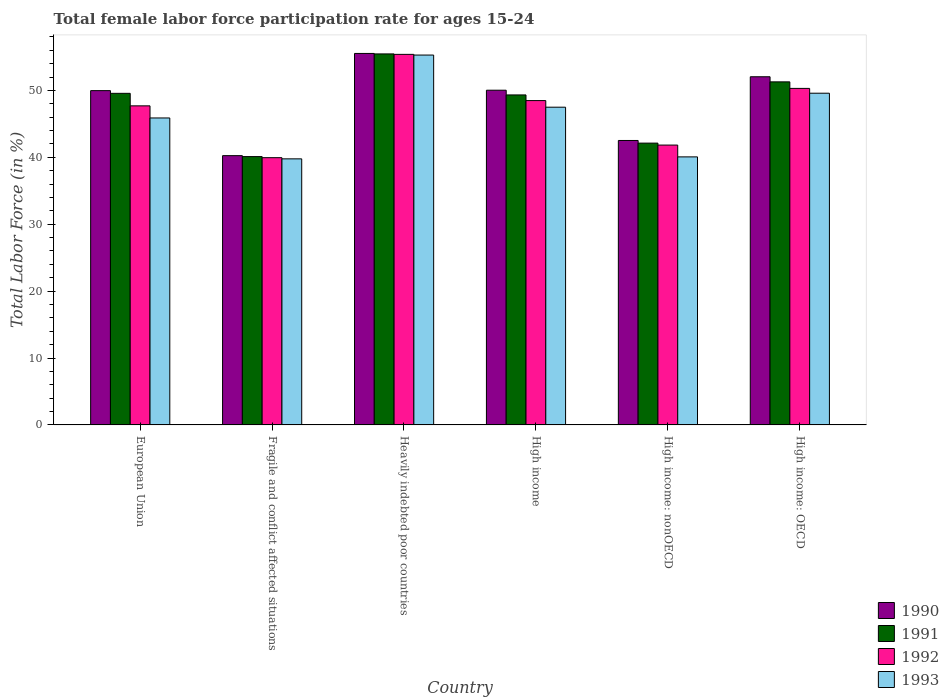How many different coloured bars are there?
Give a very brief answer. 4. How many groups of bars are there?
Give a very brief answer. 6. Are the number of bars per tick equal to the number of legend labels?
Provide a succinct answer. Yes. How many bars are there on the 1st tick from the right?
Provide a short and direct response. 4. What is the label of the 3rd group of bars from the left?
Offer a very short reply. Heavily indebted poor countries. What is the female labor force participation rate in 1991 in European Union?
Ensure brevity in your answer.  49.57. Across all countries, what is the maximum female labor force participation rate in 1992?
Offer a very short reply. 55.39. Across all countries, what is the minimum female labor force participation rate in 1992?
Give a very brief answer. 39.95. In which country was the female labor force participation rate in 1993 maximum?
Offer a terse response. Heavily indebted poor countries. In which country was the female labor force participation rate in 1990 minimum?
Give a very brief answer. Fragile and conflict affected situations. What is the total female labor force participation rate in 1991 in the graph?
Offer a very short reply. 287.87. What is the difference between the female labor force participation rate in 1991 in Fragile and conflict affected situations and that in High income: OECD?
Make the answer very short. -11.17. What is the difference between the female labor force participation rate in 1992 in High income: nonOECD and the female labor force participation rate in 1991 in High income: OECD?
Make the answer very short. -9.45. What is the average female labor force participation rate in 1991 per country?
Give a very brief answer. 47.98. What is the difference between the female labor force participation rate of/in 1991 and female labor force participation rate of/in 1990 in High income: OECD?
Provide a short and direct response. -0.76. What is the ratio of the female labor force participation rate in 1991 in Fragile and conflict affected situations to that in Heavily indebted poor countries?
Your answer should be compact. 0.72. Is the female labor force participation rate in 1992 in European Union less than that in Fragile and conflict affected situations?
Give a very brief answer. No. Is the difference between the female labor force participation rate in 1991 in European Union and High income greater than the difference between the female labor force participation rate in 1990 in European Union and High income?
Provide a short and direct response. Yes. What is the difference between the highest and the second highest female labor force participation rate in 1993?
Your answer should be compact. 2.09. What is the difference between the highest and the lowest female labor force participation rate in 1991?
Ensure brevity in your answer.  15.35. Is the sum of the female labor force participation rate in 1992 in Heavily indebted poor countries and High income greater than the maximum female labor force participation rate in 1993 across all countries?
Give a very brief answer. Yes. Is it the case that in every country, the sum of the female labor force participation rate in 1990 and female labor force participation rate in 1992 is greater than the sum of female labor force participation rate in 1991 and female labor force participation rate in 1993?
Offer a terse response. No. What does the 4th bar from the left in Fragile and conflict affected situations represents?
Your answer should be very brief. 1993. Is it the case that in every country, the sum of the female labor force participation rate in 1992 and female labor force participation rate in 1991 is greater than the female labor force participation rate in 1990?
Your answer should be compact. Yes. What is the difference between two consecutive major ticks on the Y-axis?
Your answer should be compact. 10. Are the values on the major ticks of Y-axis written in scientific E-notation?
Offer a terse response. No. Does the graph contain grids?
Keep it short and to the point. No. Where does the legend appear in the graph?
Keep it short and to the point. Bottom right. How are the legend labels stacked?
Your response must be concise. Vertical. What is the title of the graph?
Keep it short and to the point. Total female labor force participation rate for ages 15-24. What is the Total Labor Force (in %) of 1990 in European Union?
Your response must be concise. 49.97. What is the Total Labor Force (in %) of 1991 in European Union?
Provide a short and direct response. 49.57. What is the Total Labor Force (in %) of 1992 in European Union?
Your response must be concise. 47.7. What is the Total Labor Force (in %) of 1993 in European Union?
Keep it short and to the point. 45.89. What is the Total Labor Force (in %) of 1990 in Fragile and conflict affected situations?
Give a very brief answer. 40.25. What is the Total Labor Force (in %) of 1991 in Fragile and conflict affected situations?
Ensure brevity in your answer.  40.11. What is the Total Labor Force (in %) of 1992 in Fragile and conflict affected situations?
Your response must be concise. 39.95. What is the Total Labor Force (in %) of 1993 in Fragile and conflict affected situations?
Your answer should be compact. 39.77. What is the Total Labor Force (in %) of 1990 in Heavily indebted poor countries?
Your answer should be compact. 55.53. What is the Total Labor Force (in %) in 1991 in Heavily indebted poor countries?
Provide a short and direct response. 55.46. What is the Total Labor Force (in %) in 1992 in Heavily indebted poor countries?
Give a very brief answer. 55.39. What is the Total Labor Force (in %) of 1993 in Heavily indebted poor countries?
Keep it short and to the point. 55.29. What is the Total Labor Force (in %) of 1990 in High income?
Your answer should be very brief. 50.03. What is the Total Labor Force (in %) in 1991 in High income?
Offer a very short reply. 49.33. What is the Total Labor Force (in %) in 1992 in High income?
Your response must be concise. 48.48. What is the Total Labor Force (in %) of 1993 in High income?
Ensure brevity in your answer.  47.5. What is the Total Labor Force (in %) in 1990 in High income: nonOECD?
Provide a short and direct response. 42.52. What is the Total Labor Force (in %) of 1991 in High income: nonOECD?
Provide a succinct answer. 42.12. What is the Total Labor Force (in %) of 1992 in High income: nonOECD?
Offer a very short reply. 41.83. What is the Total Labor Force (in %) in 1993 in High income: nonOECD?
Make the answer very short. 40.07. What is the Total Labor Force (in %) of 1990 in High income: OECD?
Make the answer very short. 52.04. What is the Total Labor Force (in %) of 1991 in High income: OECD?
Offer a terse response. 51.28. What is the Total Labor Force (in %) of 1992 in High income: OECD?
Give a very brief answer. 50.3. What is the Total Labor Force (in %) in 1993 in High income: OECD?
Your answer should be compact. 49.59. Across all countries, what is the maximum Total Labor Force (in %) of 1990?
Offer a terse response. 55.53. Across all countries, what is the maximum Total Labor Force (in %) in 1991?
Keep it short and to the point. 55.46. Across all countries, what is the maximum Total Labor Force (in %) in 1992?
Ensure brevity in your answer.  55.39. Across all countries, what is the maximum Total Labor Force (in %) of 1993?
Keep it short and to the point. 55.29. Across all countries, what is the minimum Total Labor Force (in %) in 1990?
Offer a terse response. 40.25. Across all countries, what is the minimum Total Labor Force (in %) of 1991?
Provide a succinct answer. 40.11. Across all countries, what is the minimum Total Labor Force (in %) in 1992?
Provide a succinct answer. 39.95. Across all countries, what is the minimum Total Labor Force (in %) of 1993?
Your answer should be compact. 39.77. What is the total Total Labor Force (in %) of 1990 in the graph?
Make the answer very short. 290.35. What is the total Total Labor Force (in %) in 1991 in the graph?
Your response must be concise. 287.87. What is the total Total Labor Force (in %) of 1992 in the graph?
Ensure brevity in your answer.  283.65. What is the total Total Labor Force (in %) of 1993 in the graph?
Your answer should be compact. 278.1. What is the difference between the Total Labor Force (in %) in 1990 in European Union and that in Fragile and conflict affected situations?
Ensure brevity in your answer.  9.72. What is the difference between the Total Labor Force (in %) of 1991 in European Union and that in Fragile and conflict affected situations?
Provide a succinct answer. 9.46. What is the difference between the Total Labor Force (in %) in 1992 in European Union and that in Fragile and conflict affected situations?
Offer a very short reply. 7.75. What is the difference between the Total Labor Force (in %) in 1993 in European Union and that in Fragile and conflict affected situations?
Provide a short and direct response. 6.11. What is the difference between the Total Labor Force (in %) of 1990 in European Union and that in Heavily indebted poor countries?
Make the answer very short. -5.56. What is the difference between the Total Labor Force (in %) in 1991 in European Union and that in Heavily indebted poor countries?
Ensure brevity in your answer.  -5.89. What is the difference between the Total Labor Force (in %) in 1992 in European Union and that in Heavily indebted poor countries?
Provide a succinct answer. -7.7. What is the difference between the Total Labor Force (in %) of 1993 in European Union and that in Heavily indebted poor countries?
Offer a very short reply. -9.4. What is the difference between the Total Labor Force (in %) in 1990 in European Union and that in High income?
Your answer should be very brief. -0.06. What is the difference between the Total Labor Force (in %) in 1991 in European Union and that in High income?
Offer a terse response. 0.24. What is the difference between the Total Labor Force (in %) in 1992 in European Union and that in High income?
Provide a short and direct response. -0.79. What is the difference between the Total Labor Force (in %) in 1993 in European Union and that in High income?
Keep it short and to the point. -1.61. What is the difference between the Total Labor Force (in %) in 1990 in European Union and that in High income: nonOECD?
Ensure brevity in your answer.  7.45. What is the difference between the Total Labor Force (in %) of 1991 in European Union and that in High income: nonOECD?
Your answer should be compact. 7.44. What is the difference between the Total Labor Force (in %) in 1992 in European Union and that in High income: nonOECD?
Make the answer very short. 5.86. What is the difference between the Total Labor Force (in %) in 1993 in European Union and that in High income: nonOECD?
Your answer should be very brief. 5.82. What is the difference between the Total Labor Force (in %) in 1990 in European Union and that in High income: OECD?
Offer a very short reply. -2.07. What is the difference between the Total Labor Force (in %) in 1991 in European Union and that in High income: OECD?
Offer a terse response. -1.72. What is the difference between the Total Labor Force (in %) of 1992 in European Union and that in High income: OECD?
Your answer should be compact. -2.61. What is the difference between the Total Labor Force (in %) in 1993 in European Union and that in High income: OECD?
Ensure brevity in your answer.  -3.7. What is the difference between the Total Labor Force (in %) in 1990 in Fragile and conflict affected situations and that in Heavily indebted poor countries?
Make the answer very short. -15.28. What is the difference between the Total Labor Force (in %) in 1991 in Fragile and conflict affected situations and that in Heavily indebted poor countries?
Provide a succinct answer. -15.35. What is the difference between the Total Labor Force (in %) of 1992 in Fragile and conflict affected situations and that in Heavily indebted poor countries?
Give a very brief answer. -15.44. What is the difference between the Total Labor Force (in %) of 1993 in Fragile and conflict affected situations and that in Heavily indebted poor countries?
Your answer should be very brief. -15.52. What is the difference between the Total Labor Force (in %) in 1990 in Fragile and conflict affected situations and that in High income?
Offer a terse response. -9.78. What is the difference between the Total Labor Force (in %) in 1991 in Fragile and conflict affected situations and that in High income?
Your answer should be compact. -9.22. What is the difference between the Total Labor Force (in %) in 1992 in Fragile and conflict affected situations and that in High income?
Ensure brevity in your answer.  -8.53. What is the difference between the Total Labor Force (in %) of 1993 in Fragile and conflict affected situations and that in High income?
Give a very brief answer. -7.72. What is the difference between the Total Labor Force (in %) of 1990 in Fragile and conflict affected situations and that in High income: nonOECD?
Your response must be concise. -2.27. What is the difference between the Total Labor Force (in %) in 1991 in Fragile and conflict affected situations and that in High income: nonOECD?
Make the answer very short. -2.01. What is the difference between the Total Labor Force (in %) of 1992 in Fragile and conflict affected situations and that in High income: nonOECD?
Your response must be concise. -1.88. What is the difference between the Total Labor Force (in %) in 1993 in Fragile and conflict affected situations and that in High income: nonOECD?
Ensure brevity in your answer.  -0.29. What is the difference between the Total Labor Force (in %) in 1990 in Fragile and conflict affected situations and that in High income: OECD?
Provide a succinct answer. -11.79. What is the difference between the Total Labor Force (in %) of 1991 in Fragile and conflict affected situations and that in High income: OECD?
Ensure brevity in your answer.  -11.17. What is the difference between the Total Labor Force (in %) in 1992 in Fragile and conflict affected situations and that in High income: OECD?
Keep it short and to the point. -10.36. What is the difference between the Total Labor Force (in %) in 1993 in Fragile and conflict affected situations and that in High income: OECD?
Provide a short and direct response. -9.81. What is the difference between the Total Labor Force (in %) in 1990 in Heavily indebted poor countries and that in High income?
Offer a terse response. 5.5. What is the difference between the Total Labor Force (in %) of 1991 in Heavily indebted poor countries and that in High income?
Offer a very short reply. 6.13. What is the difference between the Total Labor Force (in %) of 1992 in Heavily indebted poor countries and that in High income?
Your response must be concise. 6.91. What is the difference between the Total Labor Force (in %) of 1993 in Heavily indebted poor countries and that in High income?
Make the answer very short. 7.79. What is the difference between the Total Labor Force (in %) of 1990 in Heavily indebted poor countries and that in High income: nonOECD?
Give a very brief answer. 13.01. What is the difference between the Total Labor Force (in %) of 1991 in Heavily indebted poor countries and that in High income: nonOECD?
Your answer should be compact. 13.34. What is the difference between the Total Labor Force (in %) in 1992 in Heavily indebted poor countries and that in High income: nonOECD?
Your response must be concise. 13.56. What is the difference between the Total Labor Force (in %) of 1993 in Heavily indebted poor countries and that in High income: nonOECD?
Your answer should be very brief. 15.22. What is the difference between the Total Labor Force (in %) in 1990 in Heavily indebted poor countries and that in High income: OECD?
Provide a short and direct response. 3.49. What is the difference between the Total Labor Force (in %) of 1991 in Heavily indebted poor countries and that in High income: OECD?
Your answer should be compact. 4.18. What is the difference between the Total Labor Force (in %) of 1992 in Heavily indebted poor countries and that in High income: OECD?
Offer a very short reply. 5.09. What is the difference between the Total Labor Force (in %) in 1993 in Heavily indebted poor countries and that in High income: OECD?
Your answer should be compact. 5.7. What is the difference between the Total Labor Force (in %) of 1990 in High income and that in High income: nonOECD?
Your answer should be very brief. 7.52. What is the difference between the Total Labor Force (in %) of 1991 in High income and that in High income: nonOECD?
Give a very brief answer. 7.2. What is the difference between the Total Labor Force (in %) in 1992 in High income and that in High income: nonOECD?
Ensure brevity in your answer.  6.65. What is the difference between the Total Labor Force (in %) in 1993 in High income and that in High income: nonOECD?
Your answer should be compact. 7.43. What is the difference between the Total Labor Force (in %) in 1990 in High income and that in High income: OECD?
Offer a very short reply. -2.01. What is the difference between the Total Labor Force (in %) of 1991 in High income and that in High income: OECD?
Your response must be concise. -1.95. What is the difference between the Total Labor Force (in %) in 1992 in High income and that in High income: OECD?
Make the answer very short. -1.82. What is the difference between the Total Labor Force (in %) of 1993 in High income and that in High income: OECD?
Your answer should be compact. -2.09. What is the difference between the Total Labor Force (in %) in 1990 in High income: nonOECD and that in High income: OECD?
Ensure brevity in your answer.  -9.53. What is the difference between the Total Labor Force (in %) in 1991 in High income: nonOECD and that in High income: OECD?
Offer a very short reply. -9.16. What is the difference between the Total Labor Force (in %) in 1992 in High income: nonOECD and that in High income: OECD?
Give a very brief answer. -8.47. What is the difference between the Total Labor Force (in %) of 1993 in High income: nonOECD and that in High income: OECD?
Your answer should be very brief. -9.52. What is the difference between the Total Labor Force (in %) in 1990 in European Union and the Total Labor Force (in %) in 1991 in Fragile and conflict affected situations?
Offer a terse response. 9.86. What is the difference between the Total Labor Force (in %) in 1990 in European Union and the Total Labor Force (in %) in 1992 in Fragile and conflict affected situations?
Give a very brief answer. 10.02. What is the difference between the Total Labor Force (in %) in 1990 in European Union and the Total Labor Force (in %) in 1993 in Fragile and conflict affected situations?
Give a very brief answer. 10.2. What is the difference between the Total Labor Force (in %) in 1991 in European Union and the Total Labor Force (in %) in 1992 in Fragile and conflict affected situations?
Offer a terse response. 9.62. What is the difference between the Total Labor Force (in %) of 1991 in European Union and the Total Labor Force (in %) of 1993 in Fragile and conflict affected situations?
Make the answer very short. 9.79. What is the difference between the Total Labor Force (in %) in 1992 in European Union and the Total Labor Force (in %) in 1993 in Fragile and conflict affected situations?
Offer a very short reply. 7.92. What is the difference between the Total Labor Force (in %) of 1990 in European Union and the Total Labor Force (in %) of 1991 in Heavily indebted poor countries?
Give a very brief answer. -5.49. What is the difference between the Total Labor Force (in %) of 1990 in European Union and the Total Labor Force (in %) of 1992 in Heavily indebted poor countries?
Your answer should be very brief. -5.42. What is the difference between the Total Labor Force (in %) of 1990 in European Union and the Total Labor Force (in %) of 1993 in Heavily indebted poor countries?
Ensure brevity in your answer.  -5.32. What is the difference between the Total Labor Force (in %) of 1991 in European Union and the Total Labor Force (in %) of 1992 in Heavily indebted poor countries?
Keep it short and to the point. -5.83. What is the difference between the Total Labor Force (in %) of 1991 in European Union and the Total Labor Force (in %) of 1993 in Heavily indebted poor countries?
Provide a short and direct response. -5.72. What is the difference between the Total Labor Force (in %) in 1992 in European Union and the Total Labor Force (in %) in 1993 in Heavily indebted poor countries?
Give a very brief answer. -7.59. What is the difference between the Total Labor Force (in %) of 1990 in European Union and the Total Labor Force (in %) of 1991 in High income?
Give a very brief answer. 0.64. What is the difference between the Total Labor Force (in %) of 1990 in European Union and the Total Labor Force (in %) of 1992 in High income?
Offer a terse response. 1.49. What is the difference between the Total Labor Force (in %) in 1990 in European Union and the Total Labor Force (in %) in 1993 in High income?
Your answer should be compact. 2.47. What is the difference between the Total Labor Force (in %) of 1991 in European Union and the Total Labor Force (in %) of 1992 in High income?
Offer a very short reply. 1.08. What is the difference between the Total Labor Force (in %) in 1991 in European Union and the Total Labor Force (in %) in 1993 in High income?
Give a very brief answer. 2.07. What is the difference between the Total Labor Force (in %) of 1992 in European Union and the Total Labor Force (in %) of 1993 in High income?
Make the answer very short. 0.2. What is the difference between the Total Labor Force (in %) of 1990 in European Union and the Total Labor Force (in %) of 1991 in High income: nonOECD?
Your answer should be very brief. 7.85. What is the difference between the Total Labor Force (in %) in 1990 in European Union and the Total Labor Force (in %) in 1992 in High income: nonOECD?
Provide a short and direct response. 8.14. What is the difference between the Total Labor Force (in %) in 1990 in European Union and the Total Labor Force (in %) in 1993 in High income: nonOECD?
Your response must be concise. 9.9. What is the difference between the Total Labor Force (in %) in 1991 in European Union and the Total Labor Force (in %) in 1992 in High income: nonOECD?
Give a very brief answer. 7.73. What is the difference between the Total Labor Force (in %) in 1991 in European Union and the Total Labor Force (in %) in 1993 in High income: nonOECD?
Your answer should be compact. 9.5. What is the difference between the Total Labor Force (in %) of 1992 in European Union and the Total Labor Force (in %) of 1993 in High income: nonOECD?
Provide a short and direct response. 7.63. What is the difference between the Total Labor Force (in %) of 1990 in European Union and the Total Labor Force (in %) of 1991 in High income: OECD?
Offer a very short reply. -1.31. What is the difference between the Total Labor Force (in %) of 1990 in European Union and the Total Labor Force (in %) of 1992 in High income: OECD?
Your response must be concise. -0.33. What is the difference between the Total Labor Force (in %) in 1990 in European Union and the Total Labor Force (in %) in 1993 in High income: OECD?
Your answer should be very brief. 0.38. What is the difference between the Total Labor Force (in %) of 1991 in European Union and the Total Labor Force (in %) of 1992 in High income: OECD?
Your answer should be very brief. -0.74. What is the difference between the Total Labor Force (in %) in 1991 in European Union and the Total Labor Force (in %) in 1993 in High income: OECD?
Provide a succinct answer. -0.02. What is the difference between the Total Labor Force (in %) in 1992 in European Union and the Total Labor Force (in %) in 1993 in High income: OECD?
Keep it short and to the point. -1.89. What is the difference between the Total Labor Force (in %) in 1990 in Fragile and conflict affected situations and the Total Labor Force (in %) in 1991 in Heavily indebted poor countries?
Provide a short and direct response. -15.21. What is the difference between the Total Labor Force (in %) in 1990 in Fragile and conflict affected situations and the Total Labor Force (in %) in 1992 in Heavily indebted poor countries?
Make the answer very short. -15.14. What is the difference between the Total Labor Force (in %) in 1990 in Fragile and conflict affected situations and the Total Labor Force (in %) in 1993 in Heavily indebted poor countries?
Keep it short and to the point. -15.04. What is the difference between the Total Labor Force (in %) of 1991 in Fragile and conflict affected situations and the Total Labor Force (in %) of 1992 in Heavily indebted poor countries?
Provide a succinct answer. -15.28. What is the difference between the Total Labor Force (in %) of 1991 in Fragile and conflict affected situations and the Total Labor Force (in %) of 1993 in Heavily indebted poor countries?
Provide a succinct answer. -15.18. What is the difference between the Total Labor Force (in %) of 1992 in Fragile and conflict affected situations and the Total Labor Force (in %) of 1993 in Heavily indebted poor countries?
Your answer should be very brief. -15.34. What is the difference between the Total Labor Force (in %) of 1990 in Fragile and conflict affected situations and the Total Labor Force (in %) of 1991 in High income?
Offer a very short reply. -9.08. What is the difference between the Total Labor Force (in %) in 1990 in Fragile and conflict affected situations and the Total Labor Force (in %) in 1992 in High income?
Offer a very short reply. -8.23. What is the difference between the Total Labor Force (in %) of 1990 in Fragile and conflict affected situations and the Total Labor Force (in %) of 1993 in High income?
Your answer should be very brief. -7.24. What is the difference between the Total Labor Force (in %) in 1991 in Fragile and conflict affected situations and the Total Labor Force (in %) in 1992 in High income?
Your response must be concise. -8.37. What is the difference between the Total Labor Force (in %) of 1991 in Fragile and conflict affected situations and the Total Labor Force (in %) of 1993 in High income?
Ensure brevity in your answer.  -7.38. What is the difference between the Total Labor Force (in %) of 1992 in Fragile and conflict affected situations and the Total Labor Force (in %) of 1993 in High income?
Offer a terse response. -7.55. What is the difference between the Total Labor Force (in %) of 1990 in Fragile and conflict affected situations and the Total Labor Force (in %) of 1991 in High income: nonOECD?
Provide a succinct answer. -1.87. What is the difference between the Total Labor Force (in %) in 1990 in Fragile and conflict affected situations and the Total Labor Force (in %) in 1992 in High income: nonOECD?
Offer a very short reply. -1.58. What is the difference between the Total Labor Force (in %) in 1990 in Fragile and conflict affected situations and the Total Labor Force (in %) in 1993 in High income: nonOECD?
Provide a succinct answer. 0.18. What is the difference between the Total Labor Force (in %) in 1991 in Fragile and conflict affected situations and the Total Labor Force (in %) in 1992 in High income: nonOECD?
Make the answer very short. -1.72. What is the difference between the Total Labor Force (in %) of 1991 in Fragile and conflict affected situations and the Total Labor Force (in %) of 1993 in High income: nonOECD?
Your response must be concise. 0.04. What is the difference between the Total Labor Force (in %) in 1992 in Fragile and conflict affected situations and the Total Labor Force (in %) in 1993 in High income: nonOECD?
Offer a terse response. -0.12. What is the difference between the Total Labor Force (in %) of 1990 in Fragile and conflict affected situations and the Total Labor Force (in %) of 1991 in High income: OECD?
Offer a very short reply. -11.03. What is the difference between the Total Labor Force (in %) of 1990 in Fragile and conflict affected situations and the Total Labor Force (in %) of 1992 in High income: OECD?
Ensure brevity in your answer.  -10.05. What is the difference between the Total Labor Force (in %) of 1990 in Fragile and conflict affected situations and the Total Labor Force (in %) of 1993 in High income: OECD?
Your response must be concise. -9.33. What is the difference between the Total Labor Force (in %) in 1991 in Fragile and conflict affected situations and the Total Labor Force (in %) in 1992 in High income: OECD?
Ensure brevity in your answer.  -10.19. What is the difference between the Total Labor Force (in %) of 1991 in Fragile and conflict affected situations and the Total Labor Force (in %) of 1993 in High income: OECD?
Provide a short and direct response. -9.48. What is the difference between the Total Labor Force (in %) of 1992 in Fragile and conflict affected situations and the Total Labor Force (in %) of 1993 in High income: OECD?
Keep it short and to the point. -9.64. What is the difference between the Total Labor Force (in %) of 1990 in Heavily indebted poor countries and the Total Labor Force (in %) of 1991 in High income?
Offer a very short reply. 6.2. What is the difference between the Total Labor Force (in %) in 1990 in Heavily indebted poor countries and the Total Labor Force (in %) in 1992 in High income?
Offer a very short reply. 7.05. What is the difference between the Total Labor Force (in %) in 1990 in Heavily indebted poor countries and the Total Labor Force (in %) in 1993 in High income?
Your answer should be compact. 8.03. What is the difference between the Total Labor Force (in %) in 1991 in Heavily indebted poor countries and the Total Labor Force (in %) in 1992 in High income?
Offer a terse response. 6.98. What is the difference between the Total Labor Force (in %) of 1991 in Heavily indebted poor countries and the Total Labor Force (in %) of 1993 in High income?
Your answer should be compact. 7.96. What is the difference between the Total Labor Force (in %) of 1992 in Heavily indebted poor countries and the Total Labor Force (in %) of 1993 in High income?
Your answer should be compact. 7.9. What is the difference between the Total Labor Force (in %) of 1990 in Heavily indebted poor countries and the Total Labor Force (in %) of 1991 in High income: nonOECD?
Keep it short and to the point. 13.4. What is the difference between the Total Labor Force (in %) of 1990 in Heavily indebted poor countries and the Total Labor Force (in %) of 1992 in High income: nonOECD?
Keep it short and to the point. 13.7. What is the difference between the Total Labor Force (in %) in 1990 in Heavily indebted poor countries and the Total Labor Force (in %) in 1993 in High income: nonOECD?
Provide a short and direct response. 15.46. What is the difference between the Total Labor Force (in %) in 1991 in Heavily indebted poor countries and the Total Labor Force (in %) in 1992 in High income: nonOECD?
Ensure brevity in your answer.  13.63. What is the difference between the Total Labor Force (in %) in 1991 in Heavily indebted poor countries and the Total Labor Force (in %) in 1993 in High income: nonOECD?
Your answer should be very brief. 15.39. What is the difference between the Total Labor Force (in %) of 1992 in Heavily indebted poor countries and the Total Labor Force (in %) of 1993 in High income: nonOECD?
Make the answer very short. 15.33. What is the difference between the Total Labor Force (in %) in 1990 in Heavily indebted poor countries and the Total Labor Force (in %) in 1991 in High income: OECD?
Make the answer very short. 4.25. What is the difference between the Total Labor Force (in %) in 1990 in Heavily indebted poor countries and the Total Labor Force (in %) in 1992 in High income: OECD?
Provide a succinct answer. 5.23. What is the difference between the Total Labor Force (in %) in 1990 in Heavily indebted poor countries and the Total Labor Force (in %) in 1993 in High income: OECD?
Give a very brief answer. 5.94. What is the difference between the Total Labor Force (in %) in 1991 in Heavily indebted poor countries and the Total Labor Force (in %) in 1992 in High income: OECD?
Provide a succinct answer. 5.16. What is the difference between the Total Labor Force (in %) in 1991 in Heavily indebted poor countries and the Total Labor Force (in %) in 1993 in High income: OECD?
Make the answer very short. 5.87. What is the difference between the Total Labor Force (in %) in 1992 in Heavily indebted poor countries and the Total Labor Force (in %) in 1993 in High income: OECD?
Give a very brief answer. 5.81. What is the difference between the Total Labor Force (in %) in 1990 in High income and the Total Labor Force (in %) in 1991 in High income: nonOECD?
Offer a terse response. 7.91. What is the difference between the Total Labor Force (in %) in 1990 in High income and the Total Labor Force (in %) in 1992 in High income: nonOECD?
Provide a succinct answer. 8.2. What is the difference between the Total Labor Force (in %) in 1990 in High income and the Total Labor Force (in %) in 1993 in High income: nonOECD?
Offer a terse response. 9.97. What is the difference between the Total Labor Force (in %) in 1991 in High income and the Total Labor Force (in %) in 1992 in High income: nonOECD?
Offer a very short reply. 7.5. What is the difference between the Total Labor Force (in %) in 1991 in High income and the Total Labor Force (in %) in 1993 in High income: nonOECD?
Offer a terse response. 9.26. What is the difference between the Total Labor Force (in %) in 1992 in High income and the Total Labor Force (in %) in 1993 in High income: nonOECD?
Offer a very short reply. 8.42. What is the difference between the Total Labor Force (in %) in 1990 in High income and the Total Labor Force (in %) in 1991 in High income: OECD?
Your answer should be very brief. -1.25. What is the difference between the Total Labor Force (in %) in 1990 in High income and the Total Labor Force (in %) in 1992 in High income: OECD?
Give a very brief answer. -0.27. What is the difference between the Total Labor Force (in %) of 1990 in High income and the Total Labor Force (in %) of 1993 in High income: OECD?
Offer a terse response. 0.45. What is the difference between the Total Labor Force (in %) of 1991 in High income and the Total Labor Force (in %) of 1992 in High income: OECD?
Offer a terse response. -0.98. What is the difference between the Total Labor Force (in %) of 1991 in High income and the Total Labor Force (in %) of 1993 in High income: OECD?
Provide a succinct answer. -0.26. What is the difference between the Total Labor Force (in %) in 1992 in High income and the Total Labor Force (in %) in 1993 in High income: OECD?
Offer a terse response. -1.1. What is the difference between the Total Labor Force (in %) of 1990 in High income: nonOECD and the Total Labor Force (in %) of 1991 in High income: OECD?
Provide a succinct answer. -8.76. What is the difference between the Total Labor Force (in %) in 1990 in High income: nonOECD and the Total Labor Force (in %) in 1992 in High income: OECD?
Offer a very short reply. -7.79. What is the difference between the Total Labor Force (in %) of 1990 in High income: nonOECD and the Total Labor Force (in %) of 1993 in High income: OECD?
Provide a succinct answer. -7.07. What is the difference between the Total Labor Force (in %) of 1991 in High income: nonOECD and the Total Labor Force (in %) of 1992 in High income: OECD?
Provide a short and direct response. -8.18. What is the difference between the Total Labor Force (in %) in 1991 in High income: nonOECD and the Total Labor Force (in %) in 1993 in High income: OECD?
Make the answer very short. -7.46. What is the difference between the Total Labor Force (in %) in 1992 in High income: nonOECD and the Total Labor Force (in %) in 1993 in High income: OECD?
Your response must be concise. -7.75. What is the average Total Labor Force (in %) in 1990 per country?
Provide a short and direct response. 48.39. What is the average Total Labor Force (in %) of 1991 per country?
Your answer should be compact. 47.98. What is the average Total Labor Force (in %) of 1992 per country?
Offer a very short reply. 47.28. What is the average Total Labor Force (in %) in 1993 per country?
Your response must be concise. 46.35. What is the difference between the Total Labor Force (in %) of 1990 and Total Labor Force (in %) of 1991 in European Union?
Make the answer very short. 0.4. What is the difference between the Total Labor Force (in %) in 1990 and Total Labor Force (in %) in 1992 in European Union?
Offer a very short reply. 2.27. What is the difference between the Total Labor Force (in %) of 1990 and Total Labor Force (in %) of 1993 in European Union?
Provide a short and direct response. 4.08. What is the difference between the Total Labor Force (in %) in 1991 and Total Labor Force (in %) in 1992 in European Union?
Your response must be concise. 1.87. What is the difference between the Total Labor Force (in %) of 1991 and Total Labor Force (in %) of 1993 in European Union?
Your answer should be very brief. 3.68. What is the difference between the Total Labor Force (in %) of 1992 and Total Labor Force (in %) of 1993 in European Union?
Your answer should be very brief. 1.81. What is the difference between the Total Labor Force (in %) of 1990 and Total Labor Force (in %) of 1991 in Fragile and conflict affected situations?
Keep it short and to the point. 0.14. What is the difference between the Total Labor Force (in %) of 1990 and Total Labor Force (in %) of 1992 in Fragile and conflict affected situations?
Provide a short and direct response. 0.3. What is the difference between the Total Labor Force (in %) in 1990 and Total Labor Force (in %) in 1993 in Fragile and conflict affected situations?
Make the answer very short. 0.48. What is the difference between the Total Labor Force (in %) in 1991 and Total Labor Force (in %) in 1992 in Fragile and conflict affected situations?
Provide a succinct answer. 0.16. What is the difference between the Total Labor Force (in %) in 1991 and Total Labor Force (in %) in 1993 in Fragile and conflict affected situations?
Offer a terse response. 0.34. What is the difference between the Total Labor Force (in %) of 1992 and Total Labor Force (in %) of 1993 in Fragile and conflict affected situations?
Provide a succinct answer. 0.18. What is the difference between the Total Labor Force (in %) in 1990 and Total Labor Force (in %) in 1991 in Heavily indebted poor countries?
Give a very brief answer. 0.07. What is the difference between the Total Labor Force (in %) of 1990 and Total Labor Force (in %) of 1992 in Heavily indebted poor countries?
Offer a very short reply. 0.14. What is the difference between the Total Labor Force (in %) of 1990 and Total Labor Force (in %) of 1993 in Heavily indebted poor countries?
Keep it short and to the point. 0.24. What is the difference between the Total Labor Force (in %) in 1991 and Total Labor Force (in %) in 1992 in Heavily indebted poor countries?
Keep it short and to the point. 0.07. What is the difference between the Total Labor Force (in %) of 1991 and Total Labor Force (in %) of 1993 in Heavily indebted poor countries?
Provide a succinct answer. 0.17. What is the difference between the Total Labor Force (in %) in 1992 and Total Labor Force (in %) in 1993 in Heavily indebted poor countries?
Offer a very short reply. 0.1. What is the difference between the Total Labor Force (in %) in 1990 and Total Labor Force (in %) in 1991 in High income?
Make the answer very short. 0.71. What is the difference between the Total Labor Force (in %) of 1990 and Total Labor Force (in %) of 1992 in High income?
Keep it short and to the point. 1.55. What is the difference between the Total Labor Force (in %) of 1990 and Total Labor Force (in %) of 1993 in High income?
Offer a very short reply. 2.54. What is the difference between the Total Labor Force (in %) of 1991 and Total Labor Force (in %) of 1992 in High income?
Provide a short and direct response. 0.85. What is the difference between the Total Labor Force (in %) of 1991 and Total Labor Force (in %) of 1993 in High income?
Offer a very short reply. 1.83. What is the difference between the Total Labor Force (in %) of 1992 and Total Labor Force (in %) of 1993 in High income?
Give a very brief answer. 0.99. What is the difference between the Total Labor Force (in %) in 1990 and Total Labor Force (in %) in 1991 in High income: nonOECD?
Provide a succinct answer. 0.39. What is the difference between the Total Labor Force (in %) in 1990 and Total Labor Force (in %) in 1992 in High income: nonOECD?
Provide a succinct answer. 0.69. What is the difference between the Total Labor Force (in %) of 1990 and Total Labor Force (in %) of 1993 in High income: nonOECD?
Your response must be concise. 2.45. What is the difference between the Total Labor Force (in %) of 1991 and Total Labor Force (in %) of 1992 in High income: nonOECD?
Offer a very short reply. 0.29. What is the difference between the Total Labor Force (in %) of 1991 and Total Labor Force (in %) of 1993 in High income: nonOECD?
Provide a short and direct response. 2.06. What is the difference between the Total Labor Force (in %) of 1992 and Total Labor Force (in %) of 1993 in High income: nonOECD?
Keep it short and to the point. 1.77. What is the difference between the Total Labor Force (in %) of 1990 and Total Labor Force (in %) of 1991 in High income: OECD?
Your answer should be compact. 0.76. What is the difference between the Total Labor Force (in %) of 1990 and Total Labor Force (in %) of 1992 in High income: OECD?
Make the answer very short. 1.74. What is the difference between the Total Labor Force (in %) in 1990 and Total Labor Force (in %) in 1993 in High income: OECD?
Provide a short and direct response. 2.46. What is the difference between the Total Labor Force (in %) in 1991 and Total Labor Force (in %) in 1992 in High income: OECD?
Ensure brevity in your answer.  0.98. What is the difference between the Total Labor Force (in %) in 1991 and Total Labor Force (in %) in 1993 in High income: OECD?
Make the answer very short. 1.7. What is the difference between the Total Labor Force (in %) of 1992 and Total Labor Force (in %) of 1993 in High income: OECD?
Make the answer very short. 0.72. What is the ratio of the Total Labor Force (in %) in 1990 in European Union to that in Fragile and conflict affected situations?
Provide a short and direct response. 1.24. What is the ratio of the Total Labor Force (in %) of 1991 in European Union to that in Fragile and conflict affected situations?
Offer a terse response. 1.24. What is the ratio of the Total Labor Force (in %) in 1992 in European Union to that in Fragile and conflict affected situations?
Ensure brevity in your answer.  1.19. What is the ratio of the Total Labor Force (in %) of 1993 in European Union to that in Fragile and conflict affected situations?
Keep it short and to the point. 1.15. What is the ratio of the Total Labor Force (in %) of 1990 in European Union to that in Heavily indebted poor countries?
Keep it short and to the point. 0.9. What is the ratio of the Total Labor Force (in %) in 1991 in European Union to that in Heavily indebted poor countries?
Give a very brief answer. 0.89. What is the ratio of the Total Labor Force (in %) in 1992 in European Union to that in Heavily indebted poor countries?
Give a very brief answer. 0.86. What is the ratio of the Total Labor Force (in %) in 1993 in European Union to that in Heavily indebted poor countries?
Keep it short and to the point. 0.83. What is the ratio of the Total Labor Force (in %) in 1990 in European Union to that in High income?
Provide a short and direct response. 1. What is the ratio of the Total Labor Force (in %) in 1991 in European Union to that in High income?
Make the answer very short. 1. What is the ratio of the Total Labor Force (in %) of 1992 in European Union to that in High income?
Provide a short and direct response. 0.98. What is the ratio of the Total Labor Force (in %) of 1993 in European Union to that in High income?
Your answer should be compact. 0.97. What is the ratio of the Total Labor Force (in %) of 1990 in European Union to that in High income: nonOECD?
Provide a short and direct response. 1.18. What is the ratio of the Total Labor Force (in %) in 1991 in European Union to that in High income: nonOECD?
Offer a very short reply. 1.18. What is the ratio of the Total Labor Force (in %) of 1992 in European Union to that in High income: nonOECD?
Make the answer very short. 1.14. What is the ratio of the Total Labor Force (in %) in 1993 in European Union to that in High income: nonOECD?
Offer a terse response. 1.15. What is the ratio of the Total Labor Force (in %) of 1990 in European Union to that in High income: OECD?
Provide a short and direct response. 0.96. What is the ratio of the Total Labor Force (in %) in 1991 in European Union to that in High income: OECD?
Provide a short and direct response. 0.97. What is the ratio of the Total Labor Force (in %) in 1992 in European Union to that in High income: OECD?
Provide a short and direct response. 0.95. What is the ratio of the Total Labor Force (in %) in 1993 in European Union to that in High income: OECD?
Keep it short and to the point. 0.93. What is the ratio of the Total Labor Force (in %) in 1990 in Fragile and conflict affected situations to that in Heavily indebted poor countries?
Offer a terse response. 0.72. What is the ratio of the Total Labor Force (in %) of 1991 in Fragile and conflict affected situations to that in Heavily indebted poor countries?
Provide a succinct answer. 0.72. What is the ratio of the Total Labor Force (in %) in 1992 in Fragile and conflict affected situations to that in Heavily indebted poor countries?
Your response must be concise. 0.72. What is the ratio of the Total Labor Force (in %) in 1993 in Fragile and conflict affected situations to that in Heavily indebted poor countries?
Make the answer very short. 0.72. What is the ratio of the Total Labor Force (in %) of 1990 in Fragile and conflict affected situations to that in High income?
Your response must be concise. 0.8. What is the ratio of the Total Labor Force (in %) of 1991 in Fragile and conflict affected situations to that in High income?
Keep it short and to the point. 0.81. What is the ratio of the Total Labor Force (in %) in 1992 in Fragile and conflict affected situations to that in High income?
Offer a terse response. 0.82. What is the ratio of the Total Labor Force (in %) in 1993 in Fragile and conflict affected situations to that in High income?
Offer a terse response. 0.84. What is the ratio of the Total Labor Force (in %) in 1990 in Fragile and conflict affected situations to that in High income: nonOECD?
Your response must be concise. 0.95. What is the ratio of the Total Labor Force (in %) of 1991 in Fragile and conflict affected situations to that in High income: nonOECD?
Your answer should be compact. 0.95. What is the ratio of the Total Labor Force (in %) of 1992 in Fragile and conflict affected situations to that in High income: nonOECD?
Your response must be concise. 0.95. What is the ratio of the Total Labor Force (in %) in 1993 in Fragile and conflict affected situations to that in High income: nonOECD?
Provide a succinct answer. 0.99. What is the ratio of the Total Labor Force (in %) of 1990 in Fragile and conflict affected situations to that in High income: OECD?
Provide a short and direct response. 0.77. What is the ratio of the Total Labor Force (in %) of 1991 in Fragile and conflict affected situations to that in High income: OECD?
Your answer should be very brief. 0.78. What is the ratio of the Total Labor Force (in %) in 1992 in Fragile and conflict affected situations to that in High income: OECD?
Give a very brief answer. 0.79. What is the ratio of the Total Labor Force (in %) in 1993 in Fragile and conflict affected situations to that in High income: OECD?
Your response must be concise. 0.8. What is the ratio of the Total Labor Force (in %) in 1990 in Heavily indebted poor countries to that in High income?
Your response must be concise. 1.11. What is the ratio of the Total Labor Force (in %) of 1991 in Heavily indebted poor countries to that in High income?
Ensure brevity in your answer.  1.12. What is the ratio of the Total Labor Force (in %) in 1992 in Heavily indebted poor countries to that in High income?
Provide a succinct answer. 1.14. What is the ratio of the Total Labor Force (in %) in 1993 in Heavily indebted poor countries to that in High income?
Give a very brief answer. 1.16. What is the ratio of the Total Labor Force (in %) in 1990 in Heavily indebted poor countries to that in High income: nonOECD?
Your response must be concise. 1.31. What is the ratio of the Total Labor Force (in %) in 1991 in Heavily indebted poor countries to that in High income: nonOECD?
Provide a succinct answer. 1.32. What is the ratio of the Total Labor Force (in %) in 1992 in Heavily indebted poor countries to that in High income: nonOECD?
Ensure brevity in your answer.  1.32. What is the ratio of the Total Labor Force (in %) of 1993 in Heavily indebted poor countries to that in High income: nonOECD?
Your response must be concise. 1.38. What is the ratio of the Total Labor Force (in %) of 1990 in Heavily indebted poor countries to that in High income: OECD?
Offer a very short reply. 1.07. What is the ratio of the Total Labor Force (in %) of 1991 in Heavily indebted poor countries to that in High income: OECD?
Make the answer very short. 1.08. What is the ratio of the Total Labor Force (in %) of 1992 in Heavily indebted poor countries to that in High income: OECD?
Offer a very short reply. 1.1. What is the ratio of the Total Labor Force (in %) of 1993 in Heavily indebted poor countries to that in High income: OECD?
Make the answer very short. 1.11. What is the ratio of the Total Labor Force (in %) in 1990 in High income to that in High income: nonOECD?
Offer a very short reply. 1.18. What is the ratio of the Total Labor Force (in %) in 1991 in High income to that in High income: nonOECD?
Provide a succinct answer. 1.17. What is the ratio of the Total Labor Force (in %) of 1992 in High income to that in High income: nonOECD?
Ensure brevity in your answer.  1.16. What is the ratio of the Total Labor Force (in %) of 1993 in High income to that in High income: nonOECD?
Your answer should be compact. 1.19. What is the ratio of the Total Labor Force (in %) in 1990 in High income to that in High income: OECD?
Provide a succinct answer. 0.96. What is the ratio of the Total Labor Force (in %) of 1991 in High income to that in High income: OECD?
Offer a very short reply. 0.96. What is the ratio of the Total Labor Force (in %) in 1992 in High income to that in High income: OECD?
Your answer should be compact. 0.96. What is the ratio of the Total Labor Force (in %) in 1993 in High income to that in High income: OECD?
Ensure brevity in your answer.  0.96. What is the ratio of the Total Labor Force (in %) of 1990 in High income: nonOECD to that in High income: OECD?
Offer a very short reply. 0.82. What is the ratio of the Total Labor Force (in %) in 1991 in High income: nonOECD to that in High income: OECD?
Provide a succinct answer. 0.82. What is the ratio of the Total Labor Force (in %) in 1992 in High income: nonOECD to that in High income: OECD?
Ensure brevity in your answer.  0.83. What is the ratio of the Total Labor Force (in %) in 1993 in High income: nonOECD to that in High income: OECD?
Your answer should be compact. 0.81. What is the difference between the highest and the second highest Total Labor Force (in %) of 1990?
Make the answer very short. 3.49. What is the difference between the highest and the second highest Total Labor Force (in %) of 1991?
Offer a terse response. 4.18. What is the difference between the highest and the second highest Total Labor Force (in %) of 1992?
Your response must be concise. 5.09. What is the difference between the highest and the second highest Total Labor Force (in %) of 1993?
Provide a short and direct response. 5.7. What is the difference between the highest and the lowest Total Labor Force (in %) of 1990?
Give a very brief answer. 15.28. What is the difference between the highest and the lowest Total Labor Force (in %) in 1991?
Keep it short and to the point. 15.35. What is the difference between the highest and the lowest Total Labor Force (in %) in 1992?
Provide a succinct answer. 15.44. What is the difference between the highest and the lowest Total Labor Force (in %) of 1993?
Provide a short and direct response. 15.52. 